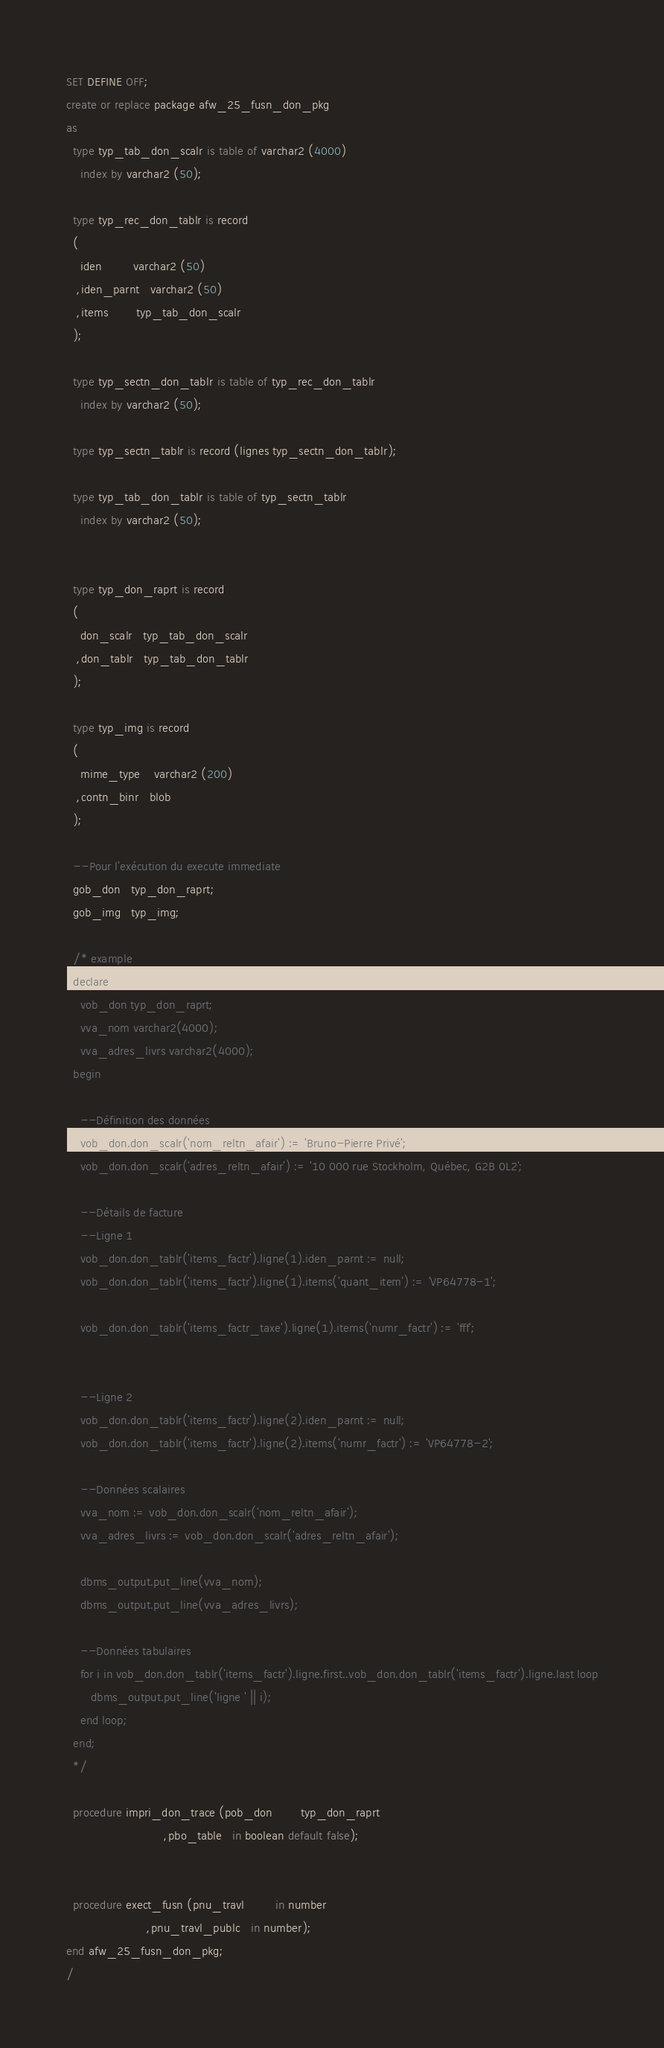Convert code to text. <code><loc_0><loc_0><loc_500><loc_500><_SQL_>SET DEFINE OFF;
create or replace package afw_25_fusn_don_pkg
as
  type typ_tab_don_scalr is table of varchar2 (4000)
    index by varchar2 (50);

  type typ_rec_don_tablr is record
  (
    iden         varchar2 (50)
   ,iden_parnt   varchar2 (50)
   ,items        typ_tab_don_scalr
  );

  type typ_sectn_don_tablr is table of typ_rec_don_tablr
    index by varchar2 (50);

  type typ_sectn_tablr is record (lignes typ_sectn_don_tablr);

  type typ_tab_don_tablr is table of typ_sectn_tablr
    index by varchar2 (50);


  type typ_don_raprt is record
  (
    don_scalr   typ_tab_don_scalr
   ,don_tablr   typ_tab_don_tablr
  );

  type typ_img is record
  (
    mime_type    varchar2 (200)
   ,contn_binr   blob
  );

  --Pour l'exécution du execute immediate
  gob_don   typ_don_raprt;
  gob_img   typ_img;

  /* example
  declare
    vob_don typ_don_raprt;
    vva_nom varchar2(4000);
    vva_adres_livrs varchar2(4000);
  begin

    --Définition des données
    vob_don.don_scalr('nom_reltn_afair') := 'Bruno-Pierre Privé';
    vob_don.don_scalr('adres_reltn_afair') := '10 000 rue Stockholm, Québec, G2B 0L2';

    --Détails de facture
    --Ligne 1
    vob_don.don_tablr('items_factr').ligne(1).iden_parnt := null;
    vob_don.don_tablr('items_factr').ligne(1).items('quant_item') := 'VP64778-1';

    vob_don.don_tablr('items_factr_taxe').ligne(1).items('numr_factr') := 'fff';


    --Ligne 2
    vob_don.don_tablr('items_factr').ligne(2).iden_parnt := null;
    vob_don.don_tablr('items_factr').ligne(2).items('numr_factr') := 'VP64778-2';

    --Données scalaires
    vva_nom := vob_don.don_scalr('nom_reltn_afair');
    vva_adres_livrs := vob_don.don_scalr('adres_reltn_afair');

    dbms_output.put_line(vva_nom);
    dbms_output.put_line(vva_adres_livrs);

    --Données tabulaires
    for i in vob_don.don_tablr('items_factr').ligne.first..vob_don.don_tablr('items_factr').ligne.last loop
       dbms_output.put_line('ligne ' || i);
    end loop;
  end;
  */

  procedure impri_don_trace (pob_don        typ_don_raprt
                            ,pbo_table   in boolean default false);


  procedure exect_fusn (pnu_travl         in number
                       ,pnu_travl_publc   in number);
end afw_25_fusn_don_pkg;
/
</code> 